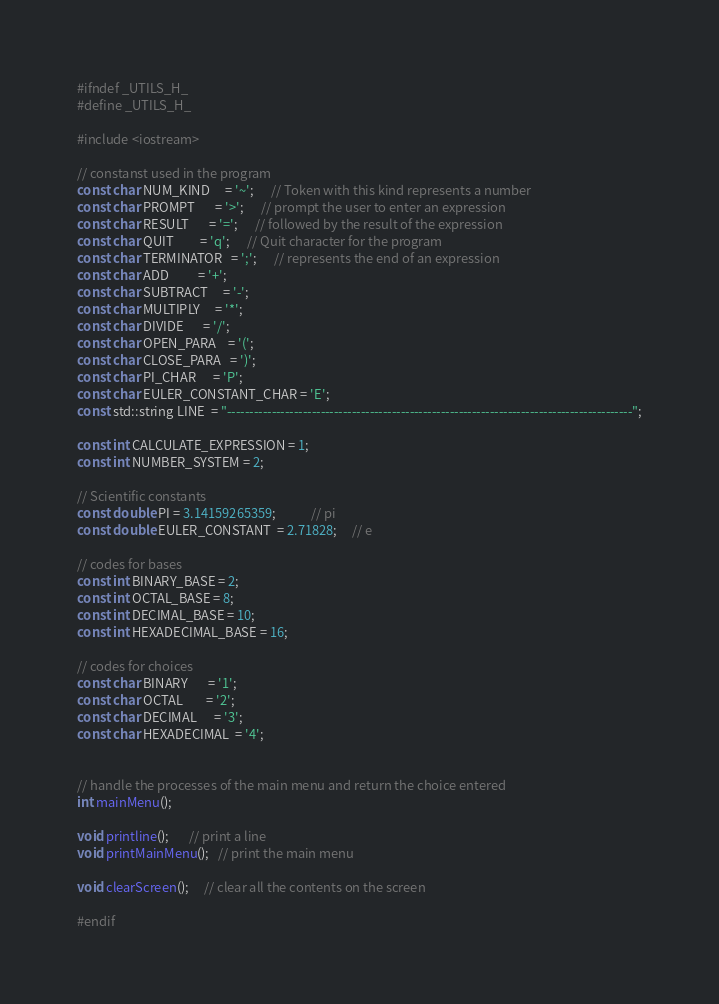<code> <loc_0><loc_0><loc_500><loc_500><_C_>#ifndef _UTILS_H_
#define _UTILS_H_

#include <iostream>

// constanst used in the program
const char NUM_KIND     = '~';      // Token with this kind represents a number
const char PROMPT       = '>';      // prompt the user to enter an expression
const char RESULT       = '=';      // followed by the result of the expression
const char QUIT         = 'q';      // Quit character for the program
const char TERMINATOR   = ';';      // represents the end of an expression
const char ADD          = '+';           
const char SUBTRACT     = '-';
const char MULTIPLY     = '*';
const char DIVIDE       = '/';
const char OPEN_PARA    = '(';
const char CLOSE_PARA   = ')';
const char PI_CHAR      = 'P';
const char EULER_CONSTANT_CHAR = 'E';
const std::string LINE  = "-------------------------------------------------------------------------------------------";

const int CALCULATE_EXPRESSION = 1;
const int NUMBER_SYSTEM = 2;

// Scientific constants
const double PI = 3.14159265359;            // pi
const double EULER_CONSTANT  = 2.71828;     // e

// codes for bases
const int BINARY_BASE = 2;
const int OCTAL_BASE = 8;
const int DECIMAL_BASE = 10;
const int HEXADECIMAL_BASE = 16;

// codes for choices
const char BINARY       = '1';
const char OCTAL        = '2';
const char DECIMAL      = '3';
const char HEXADECIMAL  = '4';


// handle the processes of the main menu and return the choice entered
int mainMenu();

void printline();       // print a line
void printMainMenu();   // print the main menu

void clearScreen();     // clear all the contents on the screen

#endif</code> 